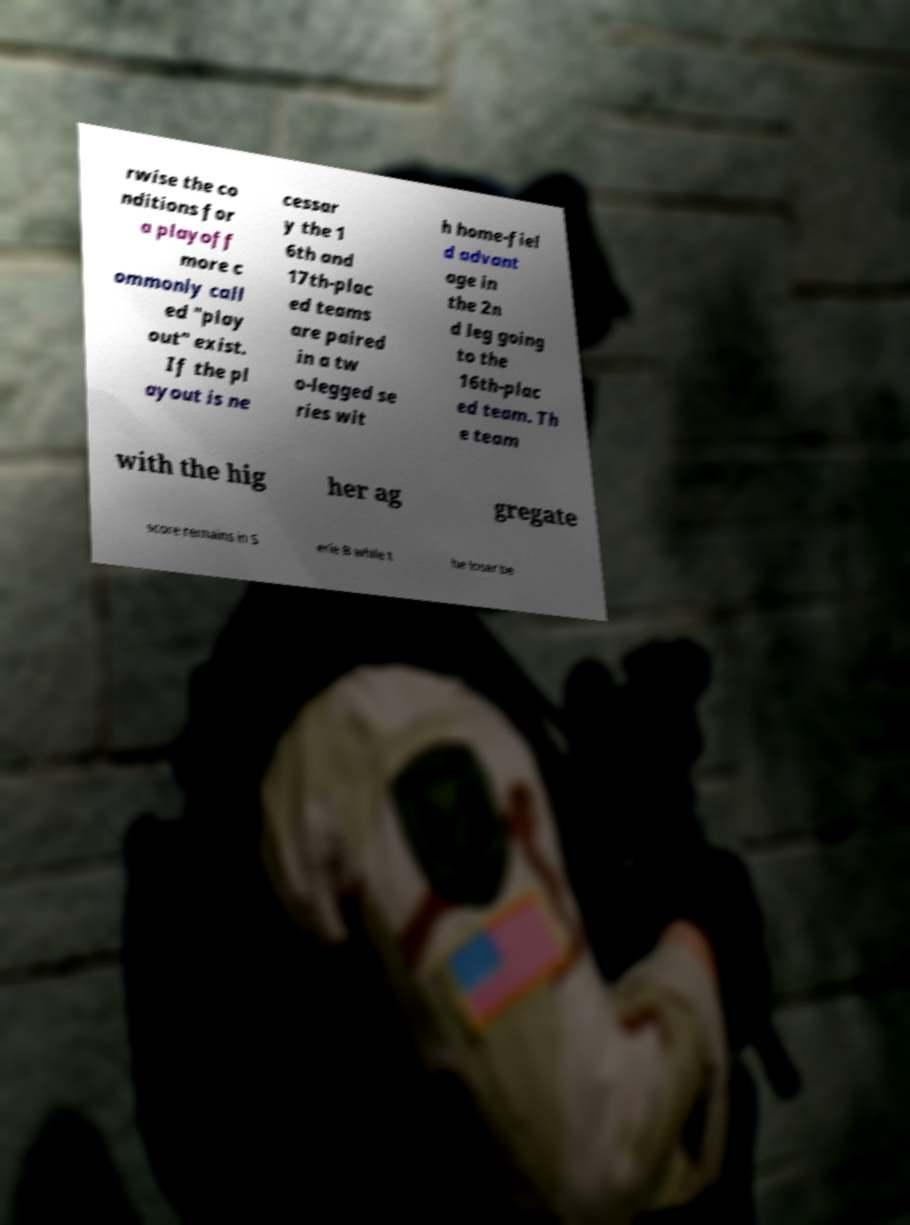Can you read and provide the text displayed in the image?This photo seems to have some interesting text. Can you extract and type it out for me? rwise the co nditions for a playoff more c ommonly call ed "play out" exist. If the pl ayout is ne cessar y the 1 6th and 17th-plac ed teams are paired in a tw o-legged se ries wit h home-fiel d advant age in the 2n d leg going to the 16th-plac ed team. Th e team with the hig her ag gregate score remains in S erie B while t he loser be 